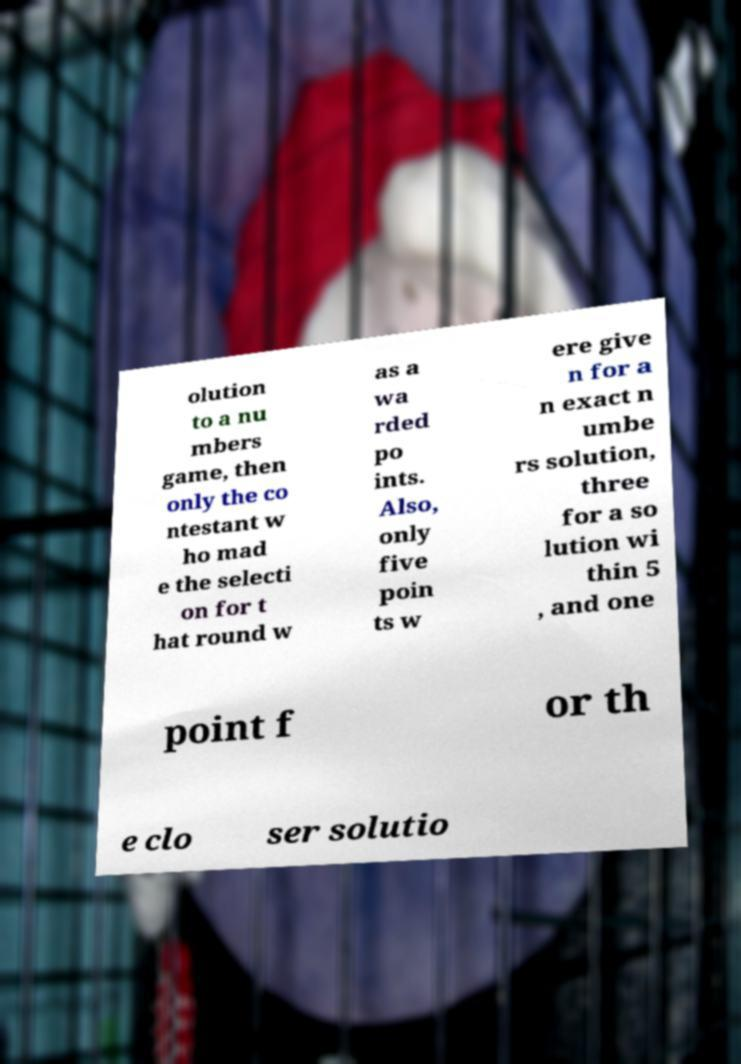I need the written content from this picture converted into text. Can you do that? olution to a nu mbers game, then only the co ntestant w ho mad e the selecti on for t hat round w as a wa rded po ints. Also, only five poin ts w ere give n for a n exact n umbe rs solution, three for a so lution wi thin 5 , and one point f or th e clo ser solutio 